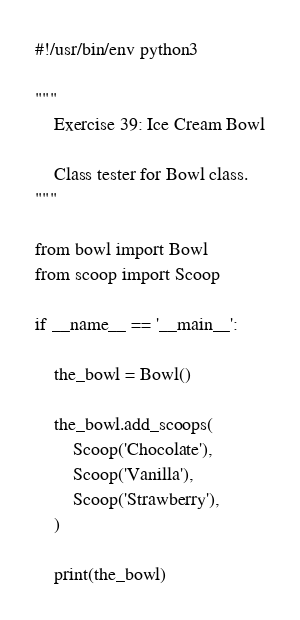<code> <loc_0><loc_0><loc_500><loc_500><_Python_>#!/usr/bin/env python3

"""
    Exercise 39: Ice Cream Bowl

    Class tester for Bowl class.
"""

from bowl import Bowl
from scoop import Scoop

if __name__ == '__main__':

    the_bowl = Bowl()

    the_bowl.add_scoops(
        Scoop('Chocolate'),
        Scoop('Vanilla'),
        Scoop('Strawberry'),
    )

    print(the_bowl)
</code> 